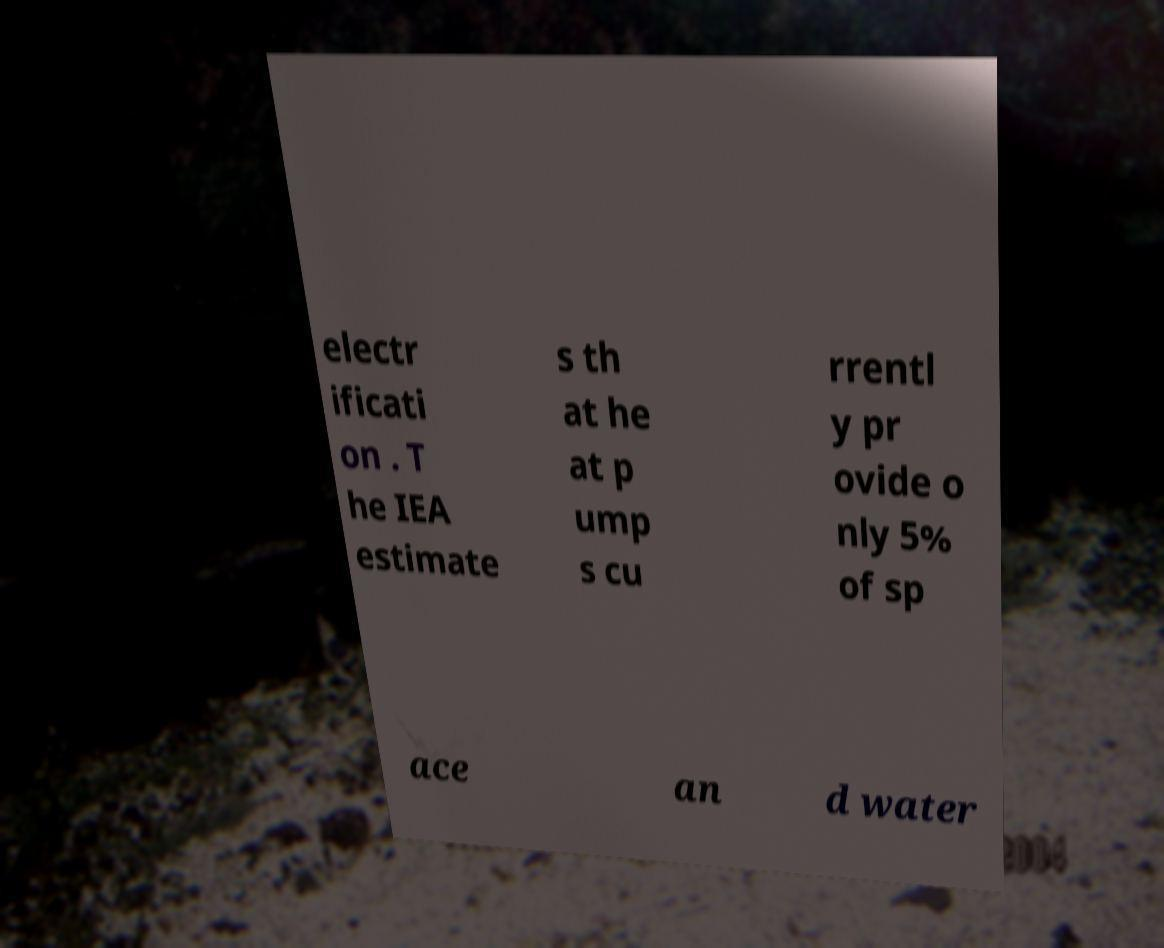Could you extract and type out the text from this image? electr ificati on . T he IEA estimate s th at he at p ump s cu rrentl y pr ovide o nly 5% of sp ace an d water 